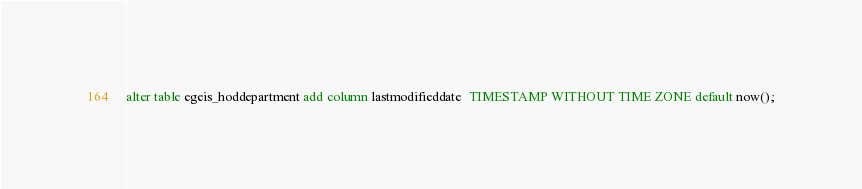<code> <loc_0><loc_0><loc_500><loc_500><_SQL_>alter table egeis_hoddepartment add column lastmodifieddate  TIMESTAMP WITHOUT TIME ZONE default now();
</code> 